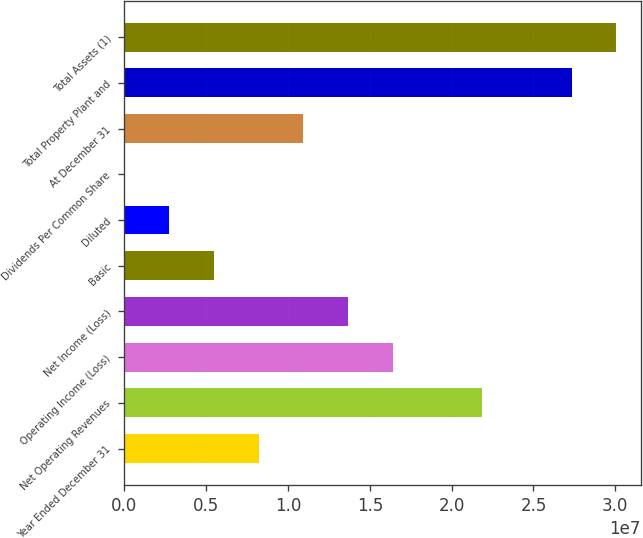Convert chart to OTSL. <chart><loc_0><loc_0><loc_500><loc_500><bar_chart><fcel>Year Ended December 31<fcel>Net Operating Revenues<fcel>Operating Income (Loss)<fcel>Net Income (Loss)<fcel>Basic<fcel>Diluted<fcel>Dividends Per Common Share<fcel>At December 31<fcel>Total Property Plant and<fcel>Total Assets (1)<nl><fcel>8.19946e+06<fcel>2.18652e+07<fcel>1.63989e+07<fcel>1.36658e+07<fcel>5.46631e+06<fcel>2.73315e+06<fcel>0.34<fcel>1.09326e+07<fcel>2.73315e+07<fcel>3.00647e+07<nl></chart> 